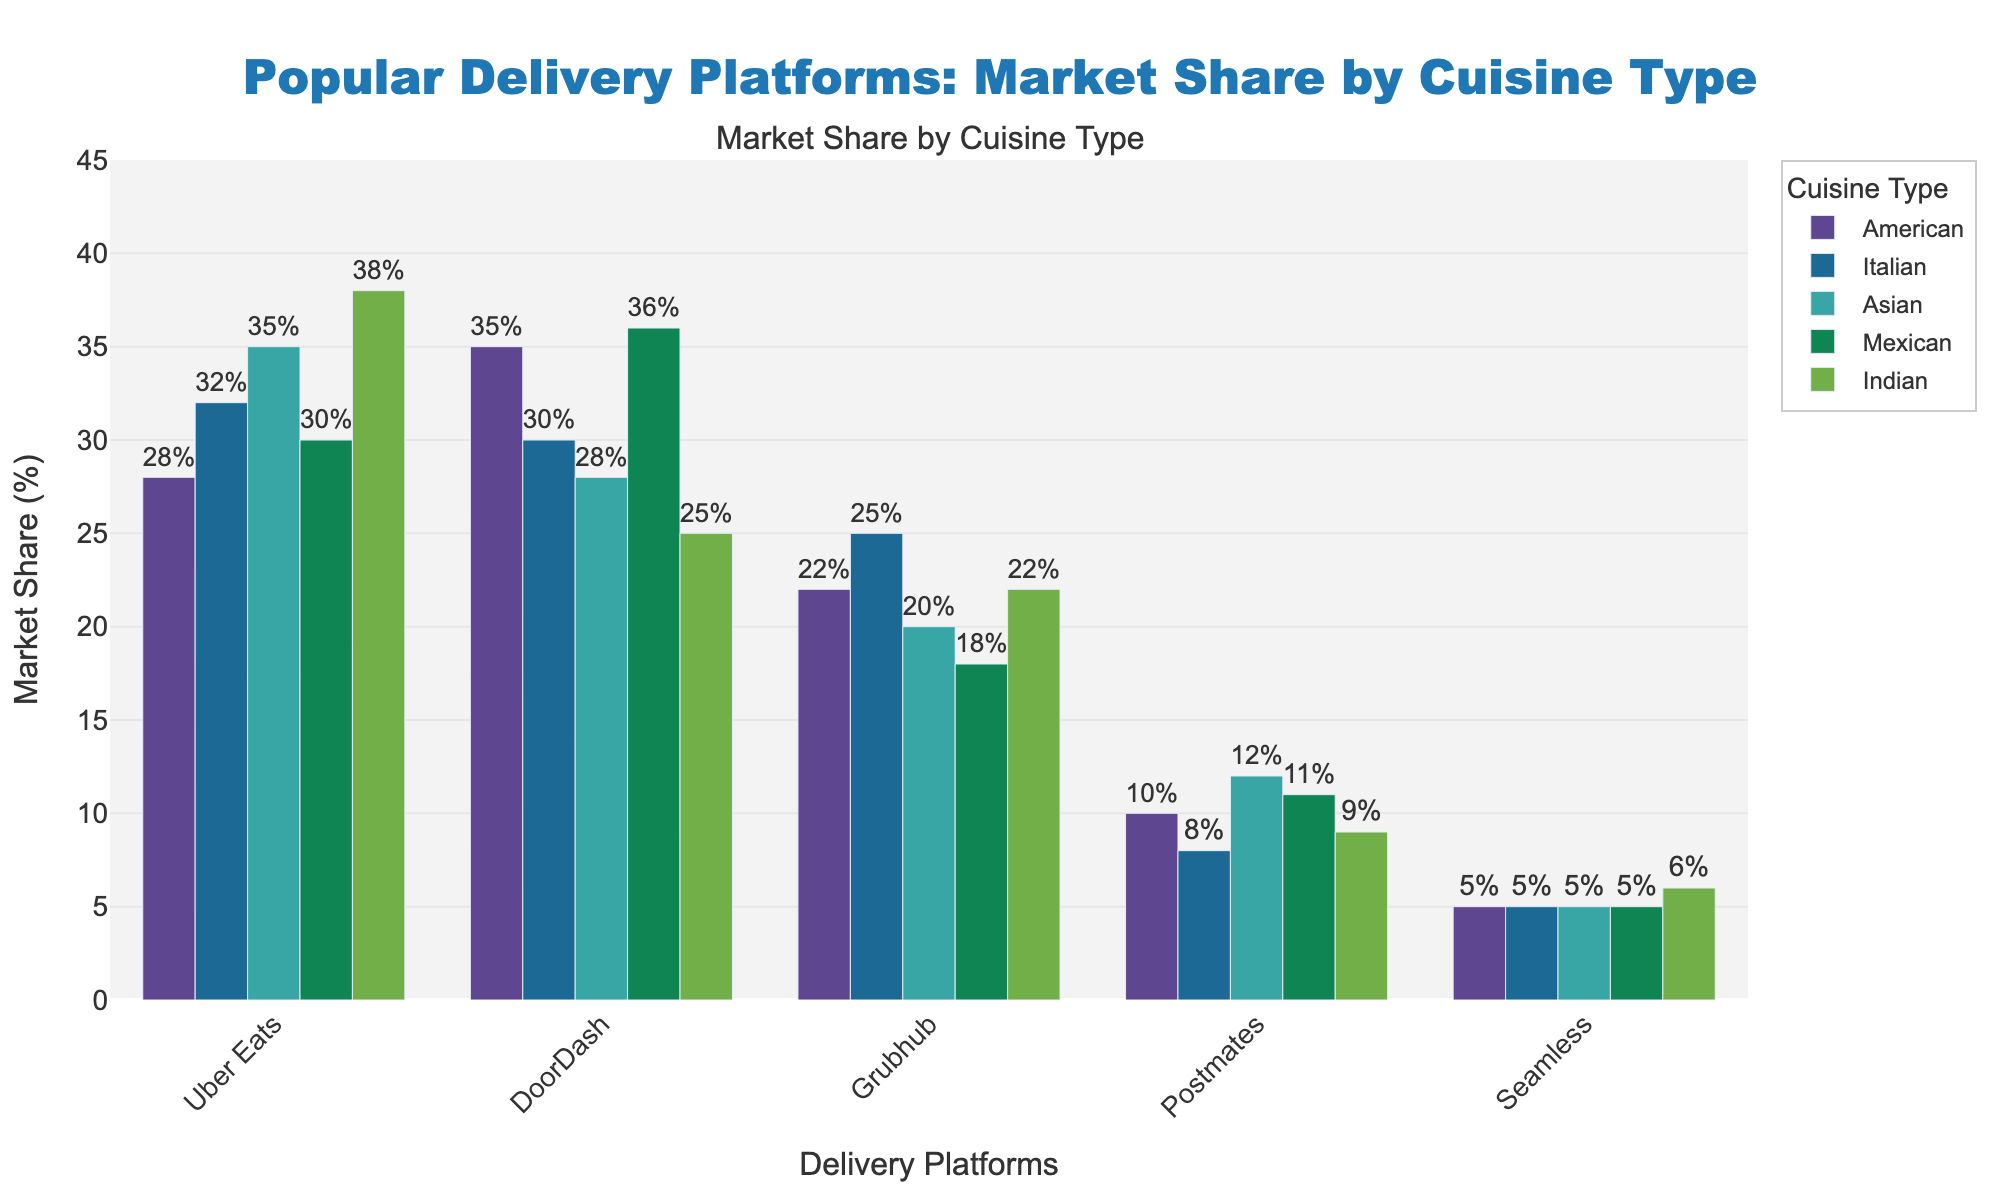Which platform has the highest market share for American cuisine? To answer this, look for the tallest bar in the "American" segment. The highest market share for American cuisine is represented by DoorDash at 35%.
Answer: DoorDash Which cuisine type does Uber Eats have the highest market share in? Review the bars corresponding to Uber Eats across different cuisines. The highest bar for Uber Eats is in the "Indian" cuisine, where it holds 38%.
Answer: Indian What is the combined market share of Grubhub for Italian and Asian cuisines? For Grubhub, identify the market share for Italian (25%) and Asian (20%) cuisines and sum these values: 25% + 20% = 45%.
Answer: 45% How does the market share of DoorDash for Mexican cuisine compare to its market share for Asian cuisine? Look at the height of DoorDash bars for Mexican (36%) and Asian (28%) cuisines. DoorDash has a higher market share in Mexican cuisine.
Answer: Mexican is higher Which cuisine has the most evenly distributed market shares across all five platforms? Compare the bars' heights for each cuisine to see which are closest in value. The "Seamless" bars are consistent (5-6%) for all cuisines, but overall, "Italian" seems most even among all platforms.
Answer: Italian What is the difference in market share for Indian cuisine between the top two platforms? The top two platforms for Indian cuisine are Uber Eats (38%) and DoorDash (25%). The difference is 38% - 25% = 13%.
Answer: 13% Which delivery platform has the smallest variance in market share across all cuisines? Evaluate the range of market shares for each platform across cuisines. "Seamless" shows little variance (5-6%), indicating the smallest variance across all cuisines.
Answer: Seamless What is the average market share of Postmates across all cuisine types? Add up the market shares for Postmates across all cuisines (10% + 8% + 12% + 11% + 9% = 50%) and then divide by the number of cuisines (5): 50% / 5 = 10%.
Answer: 10% Which platform has the lowest market share for Mexican cuisine? For Mexican cuisine, identify the shortest bar, which is "Seamless" at 5%.
Answer: Seamless 